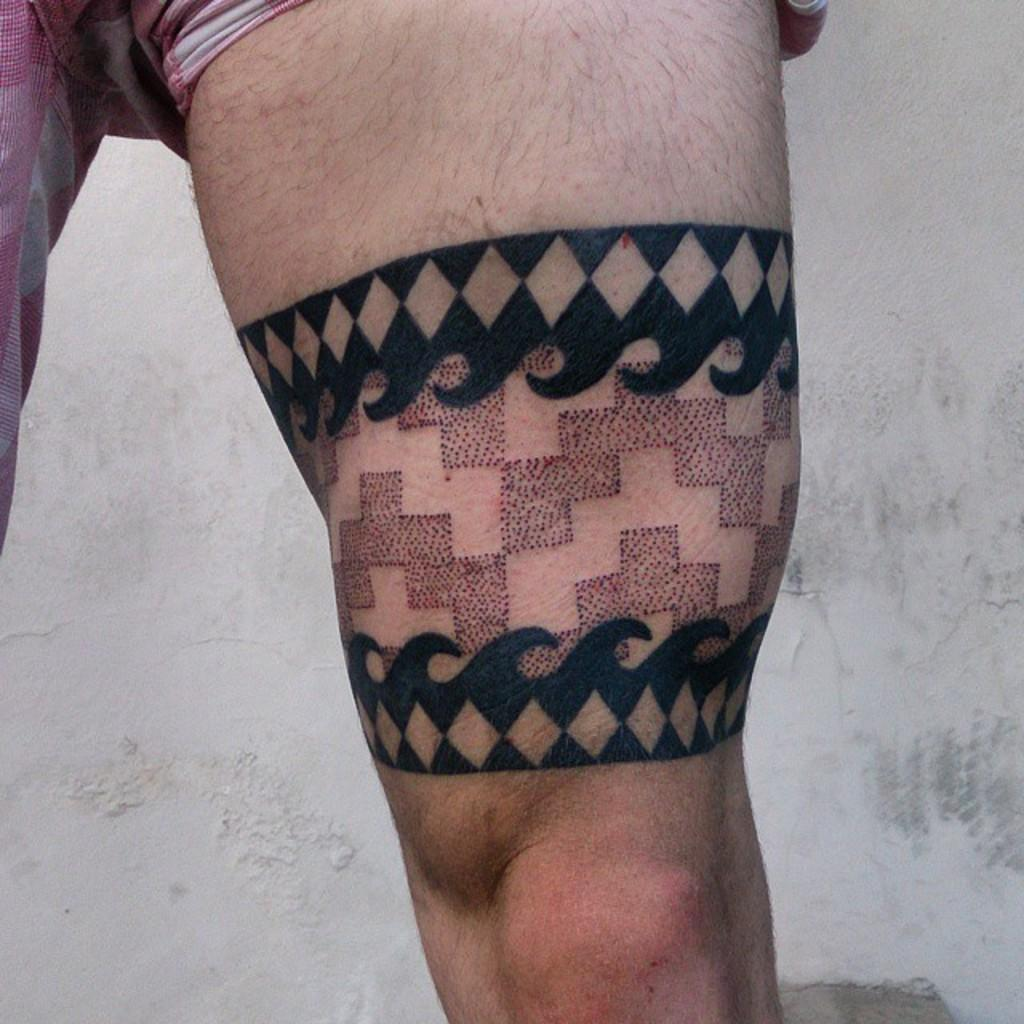Who is present in the image? There is a man in the image. What is the man wearing? The man is wearing a pink short. How much of the man's legs can be seen in the image? Only one leg of the man is visible. What is on the visible leg of the man? There is a tattoo on the visible leg. What is behind the man in the image? There is a wall behind the man. How many cats are sitting on the man's shoulder in the image? There are no cats present in the image. What type of pickle is the man holding in the image? There is no pickle present in the image. 